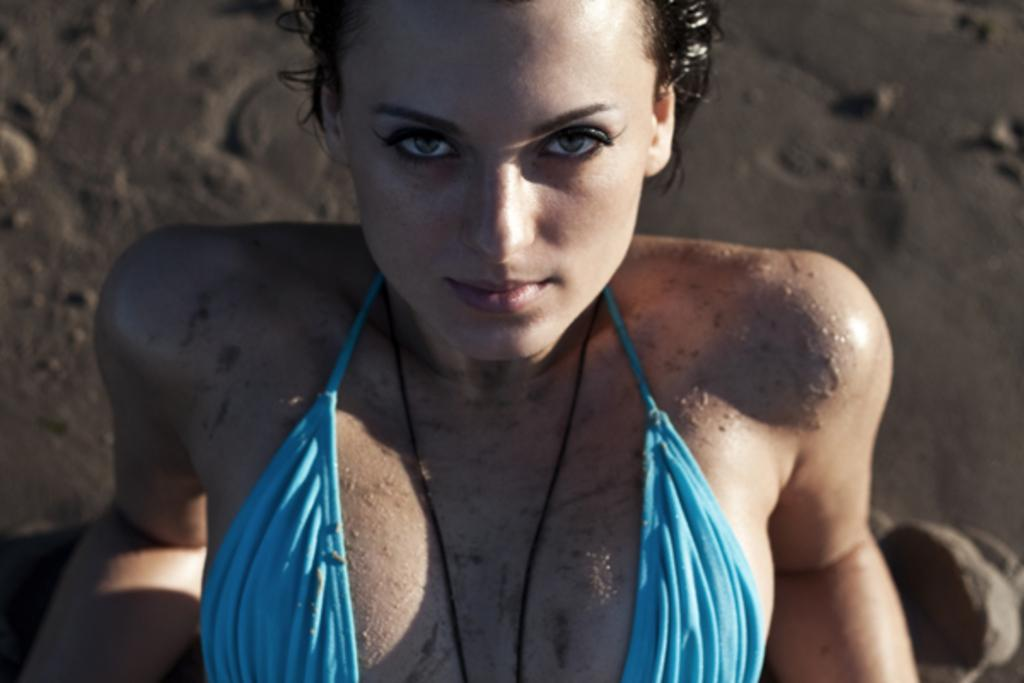Who or what is present in the image? There is a person in the image. What is the person wearing? The person is wearing a blue dress. What type of environment can be seen in the background of the image? There is sand visible in the background of the image. How much wealth does the person in the image possess? There is no information about the person's wealth in the image, so it cannot be determined. 